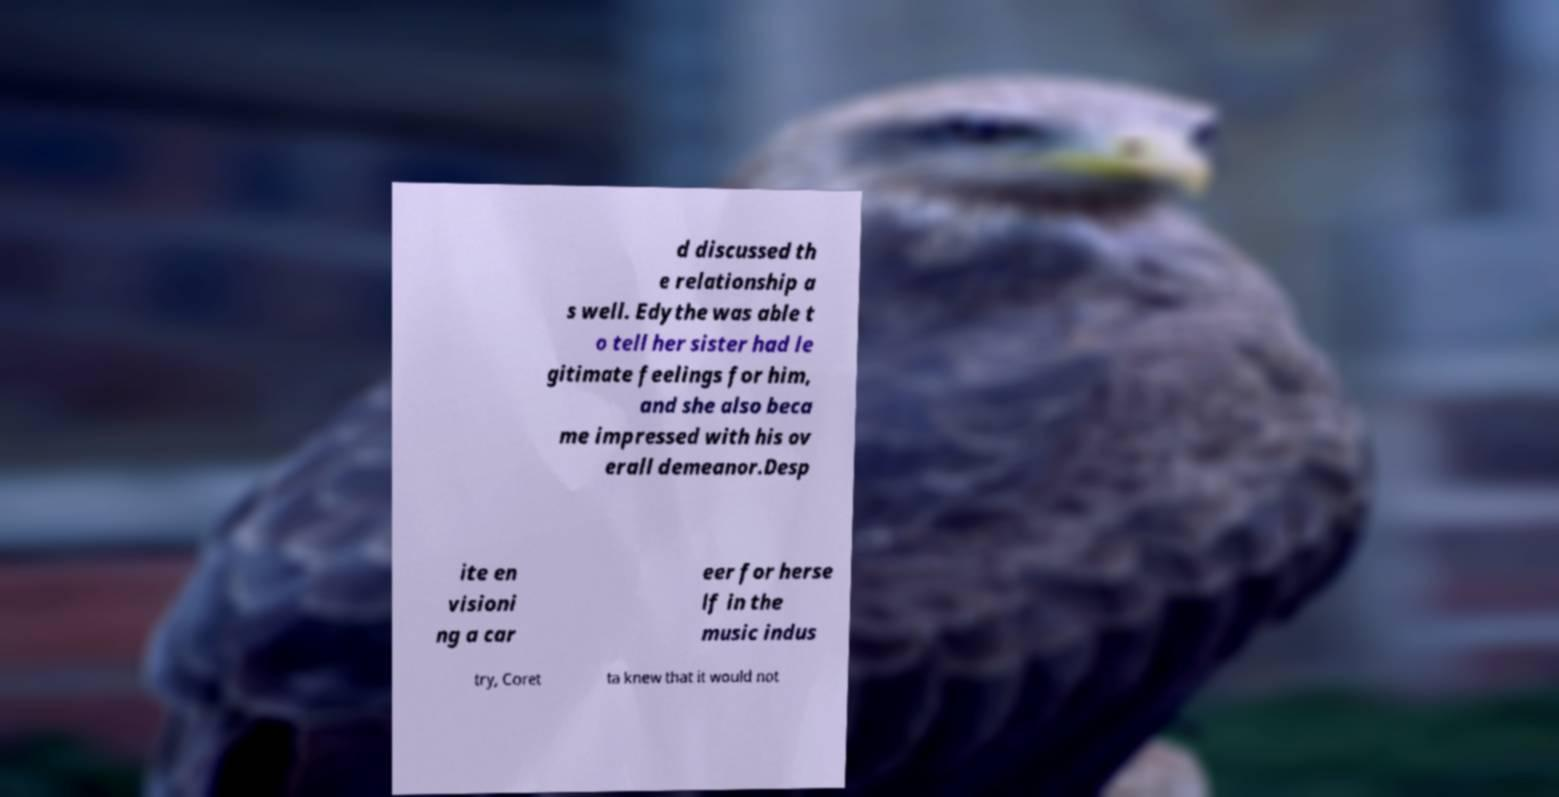I need the written content from this picture converted into text. Can you do that? d discussed th e relationship a s well. Edythe was able t o tell her sister had le gitimate feelings for him, and she also beca me impressed with his ov erall demeanor.Desp ite en visioni ng a car eer for herse lf in the music indus try, Coret ta knew that it would not 